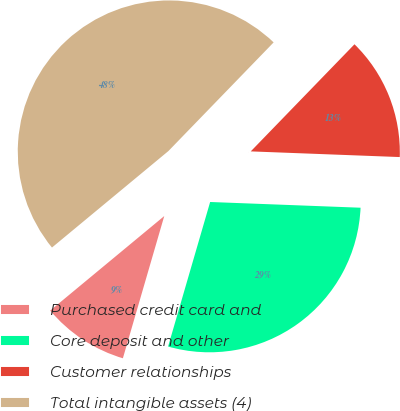Convert chart. <chart><loc_0><loc_0><loc_500><loc_500><pie_chart><fcel>Purchased credit card and<fcel>Core deposit and other<fcel>Customer relationships<fcel>Total intangible assets (4)<nl><fcel>9.48%<fcel>28.9%<fcel>13.36%<fcel>48.26%<nl></chart> 